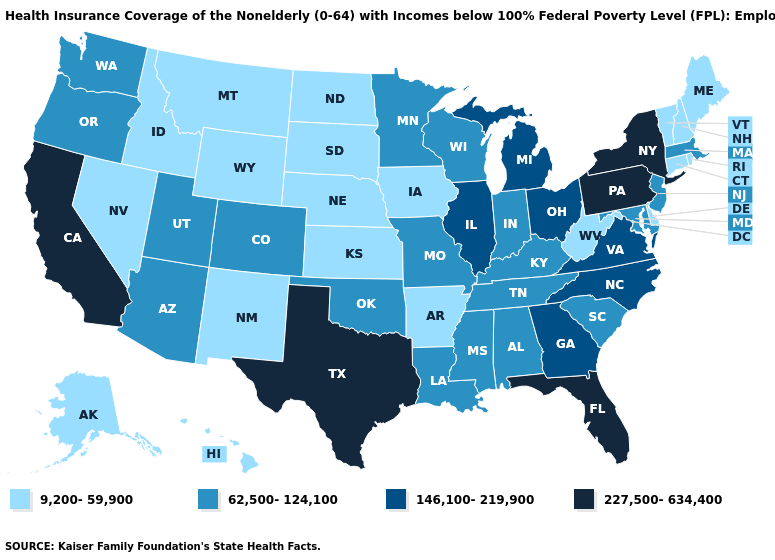Does Oregon have a higher value than Minnesota?
Keep it brief. No. Name the states that have a value in the range 227,500-634,400?
Concise answer only. California, Florida, New York, Pennsylvania, Texas. What is the highest value in the West ?
Answer briefly. 227,500-634,400. What is the value of Montana?
Concise answer only. 9,200-59,900. Name the states that have a value in the range 146,100-219,900?
Concise answer only. Georgia, Illinois, Michigan, North Carolina, Ohio, Virginia. Is the legend a continuous bar?
Short answer required. No. Name the states that have a value in the range 146,100-219,900?
Concise answer only. Georgia, Illinois, Michigan, North Carolina, Ohio, Virginia. What is the value of North Carolina?
Give a very brief answer. 146,100-219,900. What is the highest value in the South ?
Give a very brief answer. 227,500-634,400. Does Pennsylvania have the highest value in the Northeast?
Write a very short answer. Yes. What is the value of Texas?
Be succinct. 227,500-634,400. What is the value of Missouri?
Keep it brief. 62,500-124,100. Among the states that border Kansas , does Nebraska have the highest value?
Quick response, please. No. Does Kentucky have the lowest value in the USA?
Short answer required. No. 